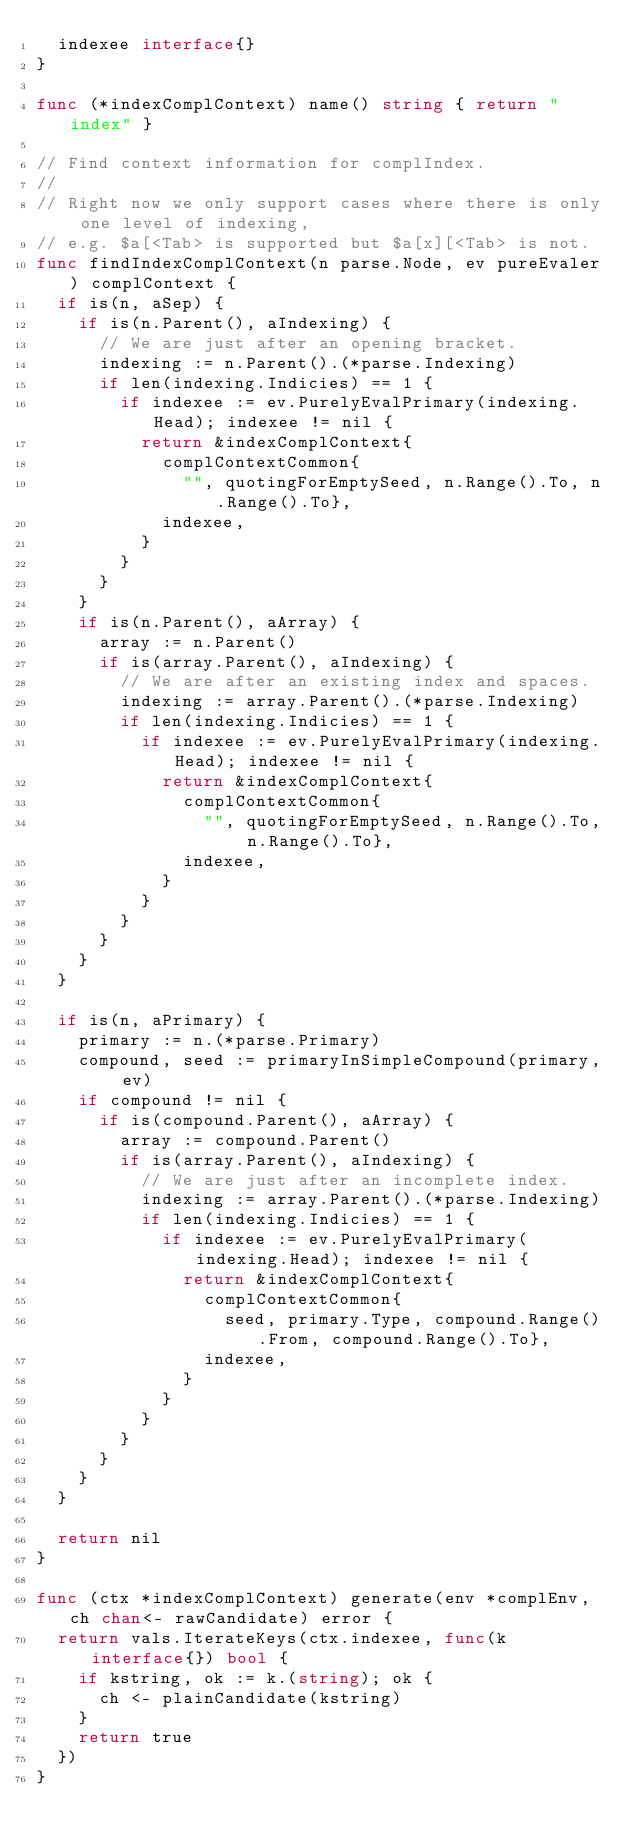Convert code to text. <code><loc_0><loc_0><loc_500><loc_500><_Go_>	indexee interface{}
}

func (*indexComplContext) name() string { return "index" }

// Find context information for complIndex.
//
// Right now we only support cases where there is only one level of indexing,
// e.g. $a[<Tab> is supported but $a[x][<Tab> is not.
func findIndexComplContext(n parse.Node, ev pureEvaler) complContext {
	if is(n, aSep) {
		if is(n.Parent(), aIndexing) {
			// We are just after an opening bracket.
			indexing := n.Parent().(*parse.Indexing)
			if len(indexing.Indicies) == 1 {
				if indexee := ev.PurelyEvalPrimary(indexing.Head); indexee != nil {
					return &indexComplContext{
						complContextCommon{
							"", quotingForEmptySeed, n.Range().To, n.Range().To},
						indexee,
					}
				}
			}
		}
		if is(n.Parent(), aArray) {
			array := n.Parent()
			if is(array.Parent(), aIndexing) {
				// We are after an existing index and spaces.
				indexing := array.Parent().(*parse.Indexing)
				if len(indexing.Indicies) == 1 {
					if indexee := ev.PurelyEvalPrimary(indexing.Head); indexee != nil {
						return &indexComplContext{
							complContextCommon{
								"", quotingForEmptySeed, n.Range().To, n.Range().To},
							indexee,
						}
					}
				}
			}
		}
	}

	if is(n, aPrimary) {
		primary := n.(*parse.Primary)
		compound, seed := primaryInSimpleCompound(primary, ev)
		if compound != nil {
			if is(compound.Parent(), aArray) {
				array := compound.Parent()
				if is(array.Parent(), aIndexing) {
					// We are just after an incomplete index.
					indexing := array.Parent().(*parse.Indexing)
					if len(indexing.Indicies) == 1 {
						if indexee := ev.PurelyEvalPrimary(indexing.Head); indexee != nil {
							return &indexComplContext{
								complContextCommon{
									seed, primary.Type, compound.Range().From, compound.Range().To},
								indexee,
							}
						}
					}
				}
			}
		}
	}

	return nil
}

func (ctx *indexComplContext) generate(env *complEnv, ch chan<- rawCandidate) error {
	return vals.IterateKeys(ctx.indexee, func(k interface{}) bool {
		if kstring, ok := k.(string); ok {
			ch <- plainCandidate(kstring)
		}
		return true
	})
}
</code> 